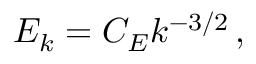<formula> <loc_0><loc_0><loc_500><loc_500>E _ { k } = C _ { E } k ^ { - 3 / 2 } \, ,</formula> 